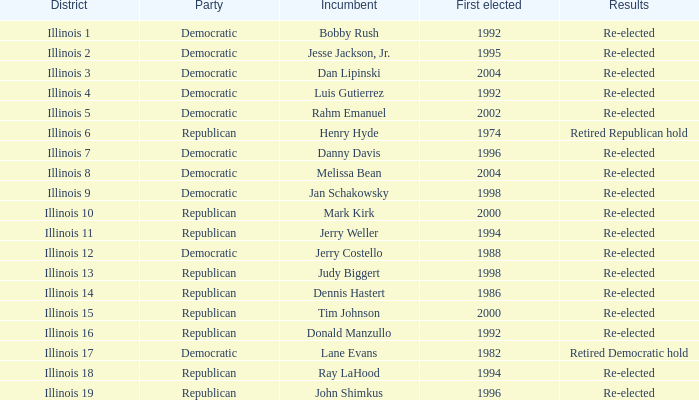What is Illinois 13 District's Party? Republican. 